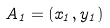Convert formula to latex. <formula><loc_0><loc_0><loc_500><loc_500>A _ { 1 } = ( x _ { 1 } , y _ { 1 } )</formula> 